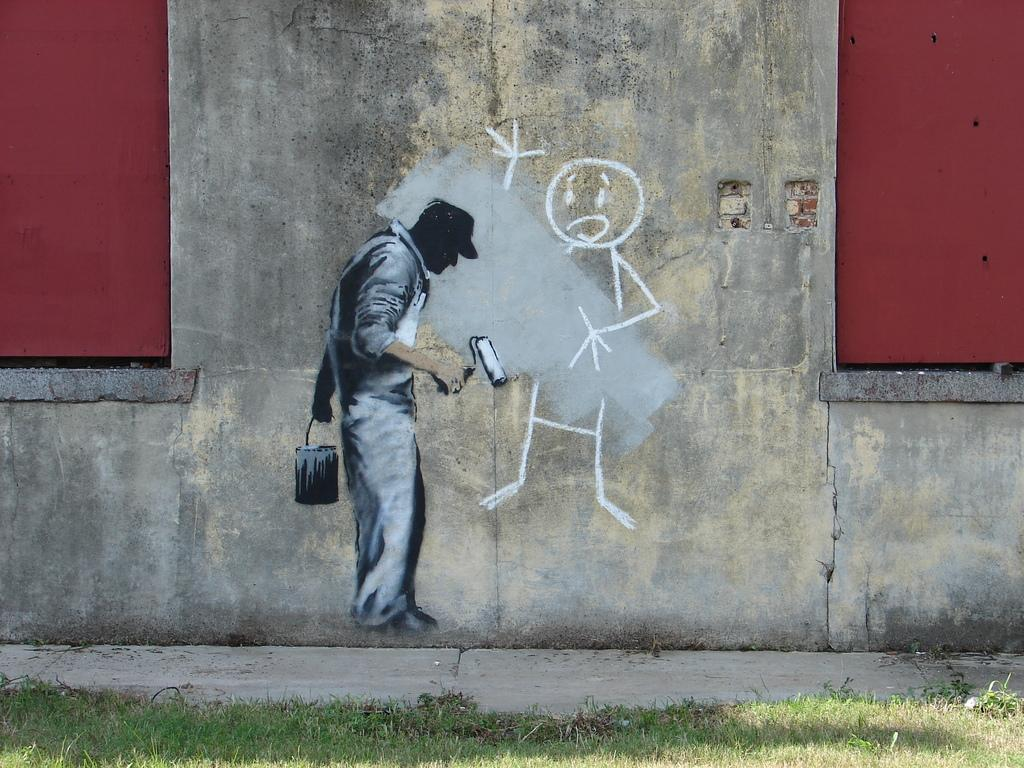What is depicted on the wall in the image? There is a picture of a man painting on the wall. What type of vegetation can be seen in the foreground of the image? There is grass visible in the foreground of the image. What is the taste of the pot in the image? There is no pot present in the image, and therefore no taste can be determined. 